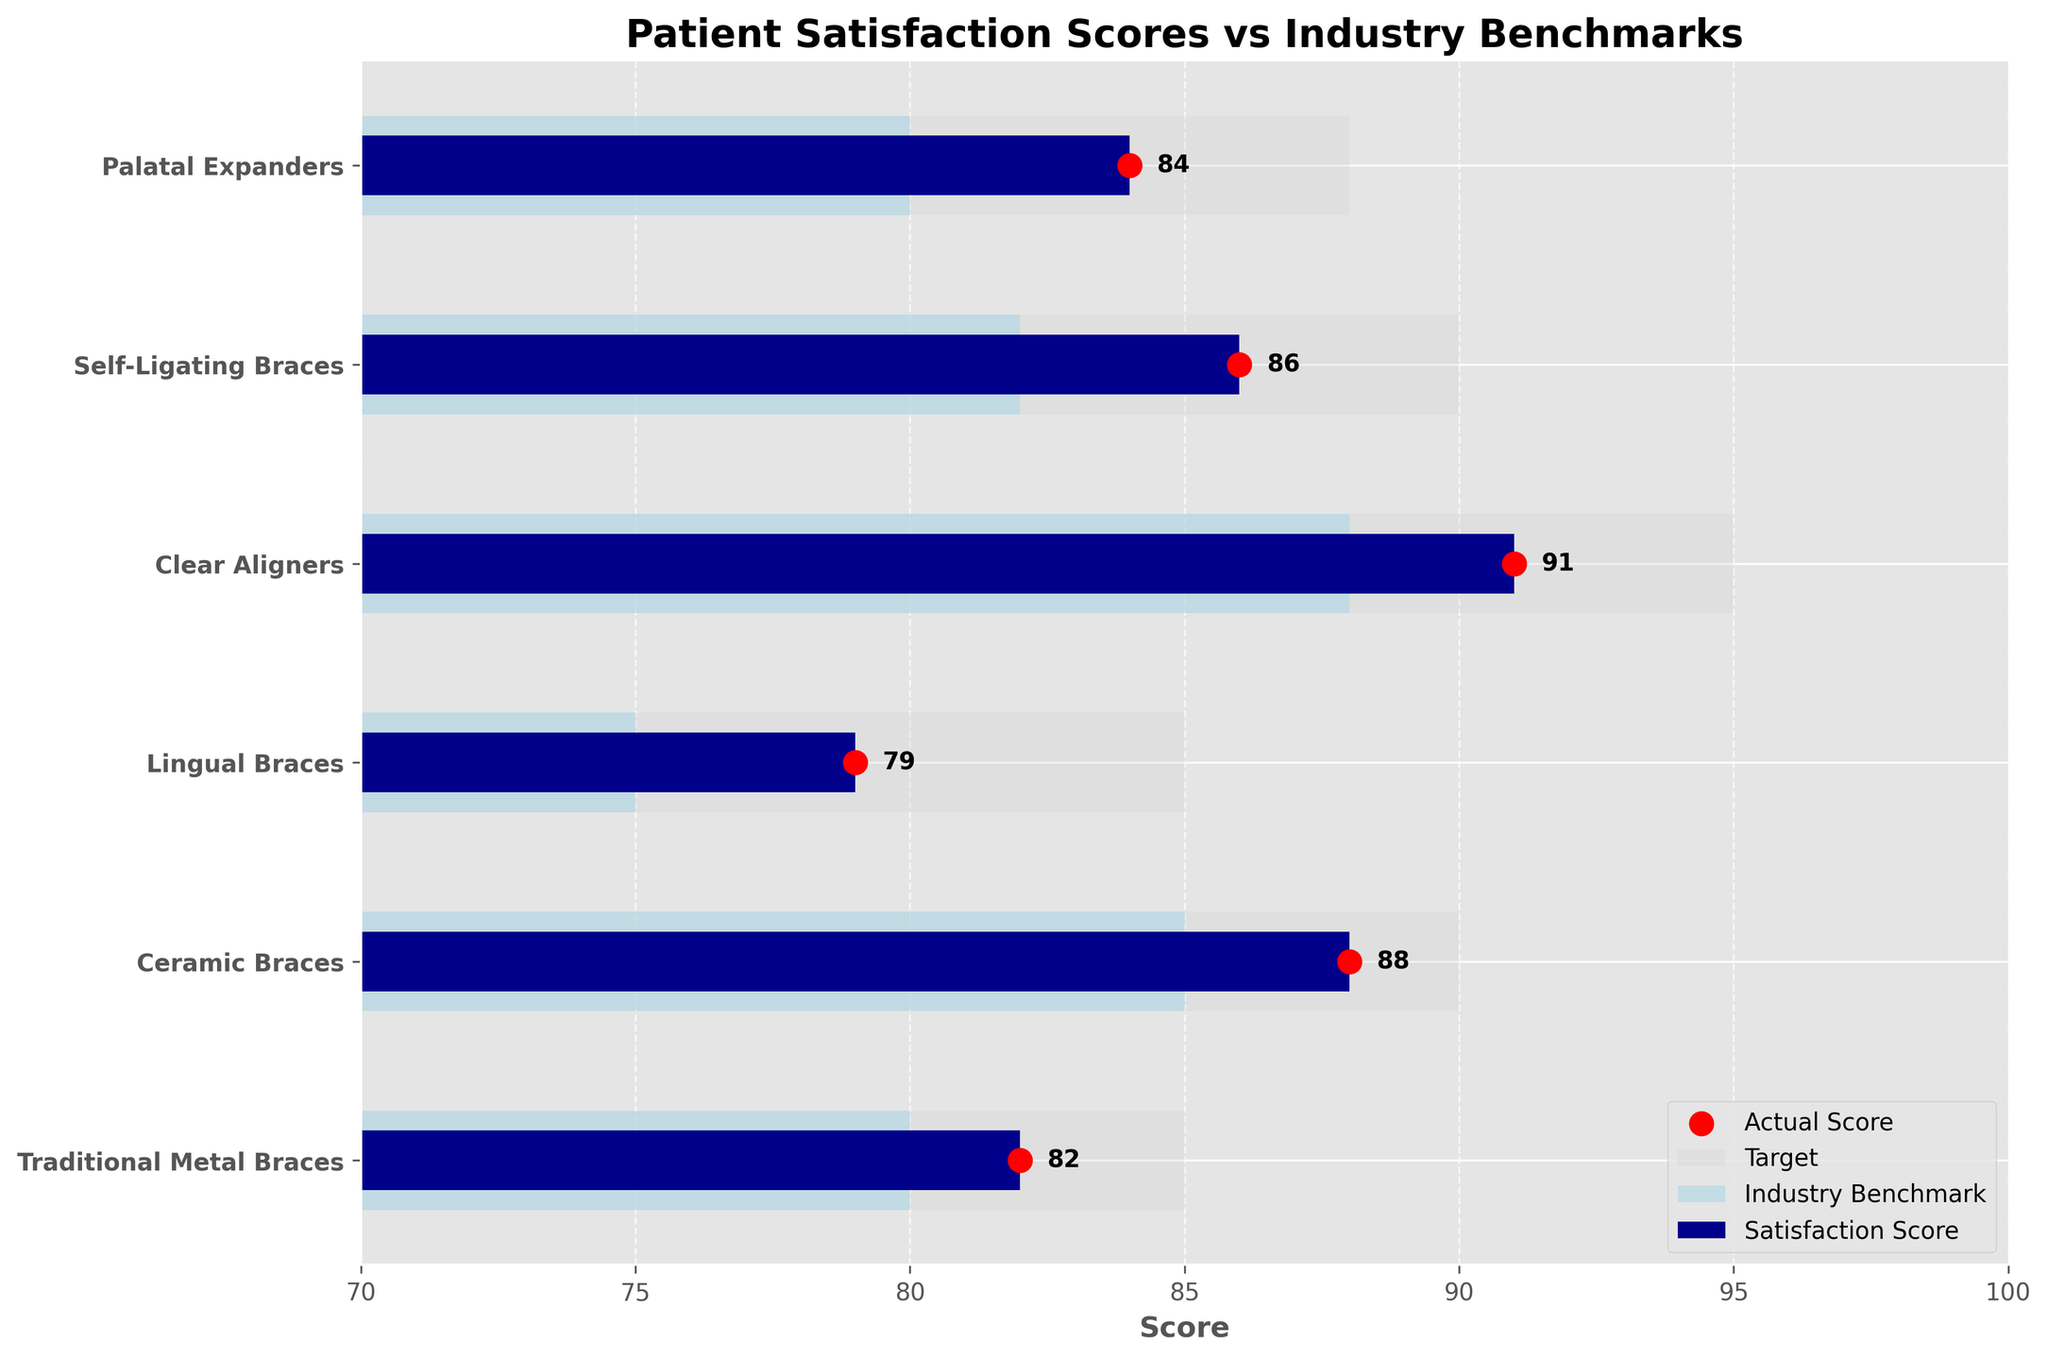What is the highest patient satisfaction score? The highest patient satisfaction score can be identified by looking at the top value among the satisfaction scores. In this case, it is for Clear Aligners with a score of 91.
Answer: 91 What is the title of the figure? The title is located at the top of the chart. It reads "Patient Satisfaction Scores vs Industry Benchmarks."
Answer: Patient Satisfaction Scores vs Industry Benchmarks Which procedure has the closest satisfaction score to its industry benchmark? To answer this, compare the satisfaction scores and industry benchmarks for each procedure to see which pair has the smallest difference. For Ceramic Braces, the satisfaction score is 88, and the benchmark is 85, making the difference 3 — the smallest in comparison to others.
Answer: Ceramic Braces How many procedures are represented in the chart? The chart shows the procedures listed along the y-axis. Counting these gives a total of 6 procedures.
Answer: 6 What's the average satisfaction score across all procedures? Sum the satisfaction scores and then divide by the number of procedures. The sum is (82 + 88 + 79 + 91 + 86 + 84) = 510. The number of procedures is 6. Thus, the average is 510 / 6 = 85.
Answer: 85 Compare the satisfaction score for Self-Ligating Braces to its target. Is it above or below the target? The satisfaction score for Self-Ligating Braces is 86 and its target is 90. Since 86 is below 90, it is below the target.
Answer: Below Which procedure exceeds its industry benchmark the most? Calculate the difference between satisfaction score and industry benchmark for each procedure and identify the largest difference. For Clear Aligners, the score is 91 and the benchmark is 88, giving a difference of 3, which is the largest.
Answer: Clear Aligners Are there any procedures where the satisfaction score matches the industry benchmark? Check if any satisfaction scores are equal to their respective industry benchmarks. None of the satisfaction scores equal their industry benchmarks.
Answer: No What is the range of patient satisfaction scores? Identify the highest and lowest satisfaction scores, then subtract the lowest from the highest. The highest score is 91 (Clear Aligners) and the lowest is 79 (Lingual Braces), thus the range is 91 - 79 = 12.
Answer: 12 